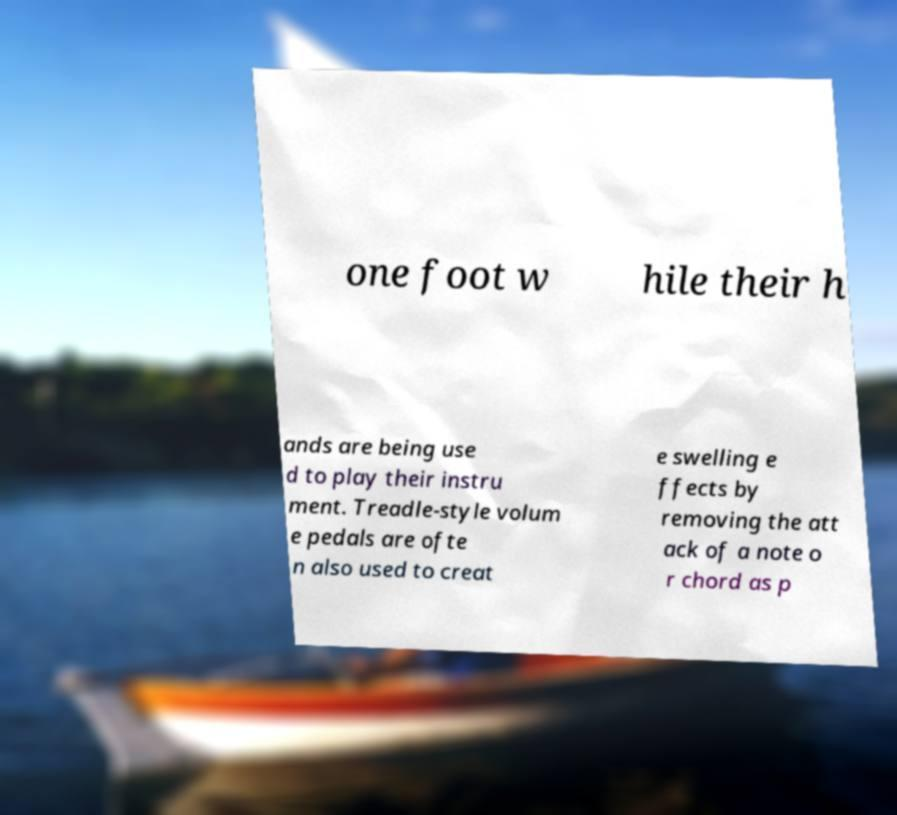Can you accurately transcribe the text from the provided image for me? one foot w hile their h ands are being use d to play their instru ment. Treadle-style volum e pedals are ofte n also used to creat e swelling e ffects by removing the att ack of a note o r chord as p 